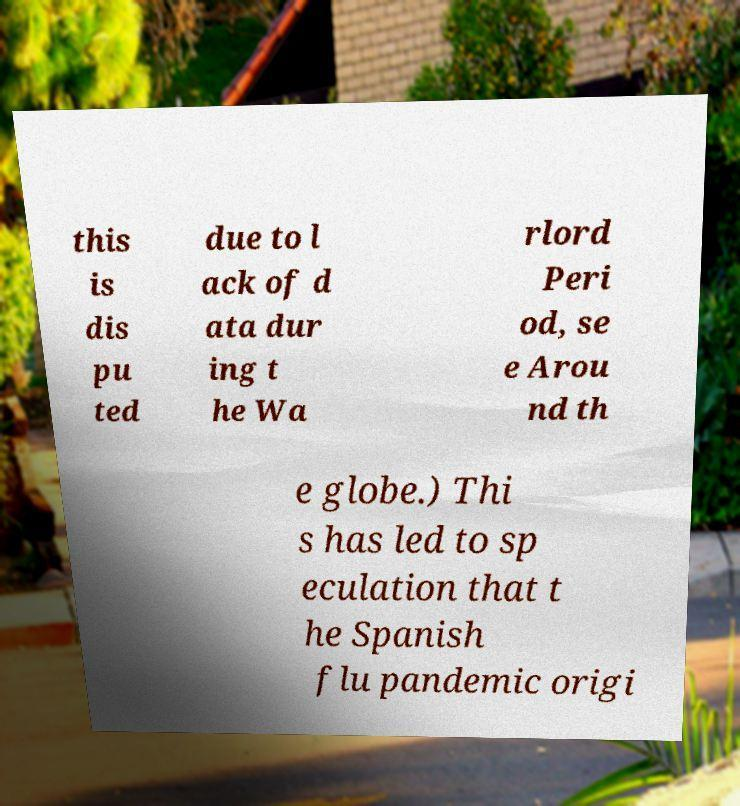Can you read and provide the text displayed in the image?This photo seems to have some interesting text. Can you extract and type it out for me? this is dis pu ted due to l ack of d ata dur ing t he Wa rlord Peri od, se e Arou nd th e globe.) Thi s has led to sp eculation that t he Spanish flu pandemic origi 